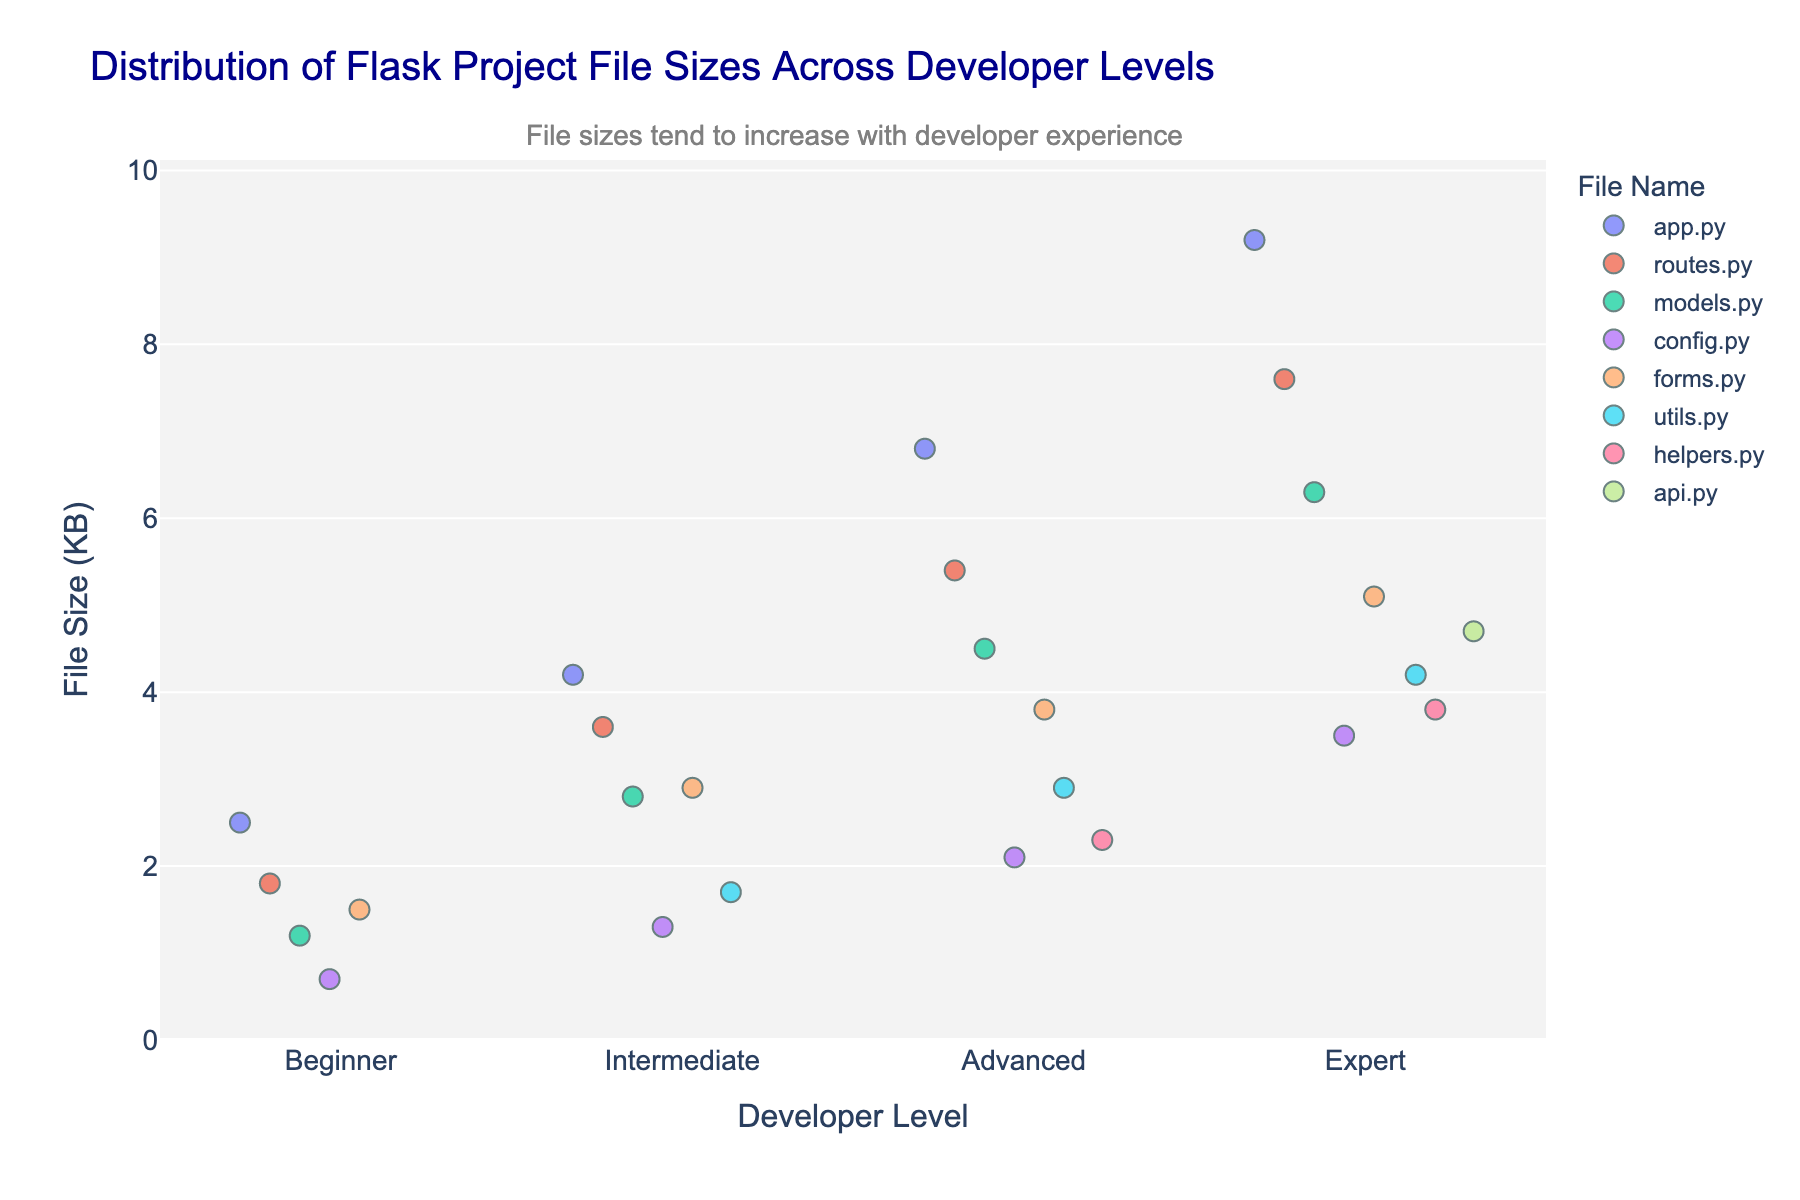How many different file types are displayed in the plot? Look at the legend in the plot, which shows different file names represented by various colors. Each file name corresponds to a file type. Count the number of unique file names listed in the legend.
Answer: 8 Which developer level has the smallest file size for 'app.py'? Examine the 'app.py' data points across all developer levels. The sizes are given in the y-axis, and the different levels are separated along the x-axis. Identify the smallest value.
Answer: Beginner What is the average file size of 'models.py' files among all developer levels? Check the file size for 'models.py' at each developer level from the plot. The values are: 1.2 KB, 2.8 KB, 4.5 KB, 6.3 KB. Calculate the average by summing these values and dividing by the number of data points (4). Calculation: (1.2 + 2.8 + 4.5 + 6.3) / 4
Answer: 3.7 KB Which developer level has the highest maximum file size? Identify the highest point on the y-axis for each developer level and see which category this data point belongs to. The highest point overall represents the maximum file size.
Answer: Expert Do intermediate developers have a larger average file size than beginners for 'routes.py'? Compare the average file sizes of 'routes.py' files for Beginner (1.8 KB) and Intermediate (3.6 KB) levels. Average for Intermediate is larger than for the Beginner.
Answer: Yes How does the file size of 'config.py' compare between advanced and expert levels? Locate the 'config.py' data points for Advanced (2.1 KB) and Expert (3.5 KB) levels. Compare these values directly.
Answer: Expert files are larger Is there any trend in file sizes as developer experience increases? Observe the overall distribution and spread of file sizes for different developer levels. The annotation in the plot also provides insight into trends.
Answer: File sizes tend to increase Which file has the most variability in size across all developer levels? Look at each file type in the plot and identify which file has the largest spread or variation in the y-axis values among all developer levels.
Answer: forms.py 